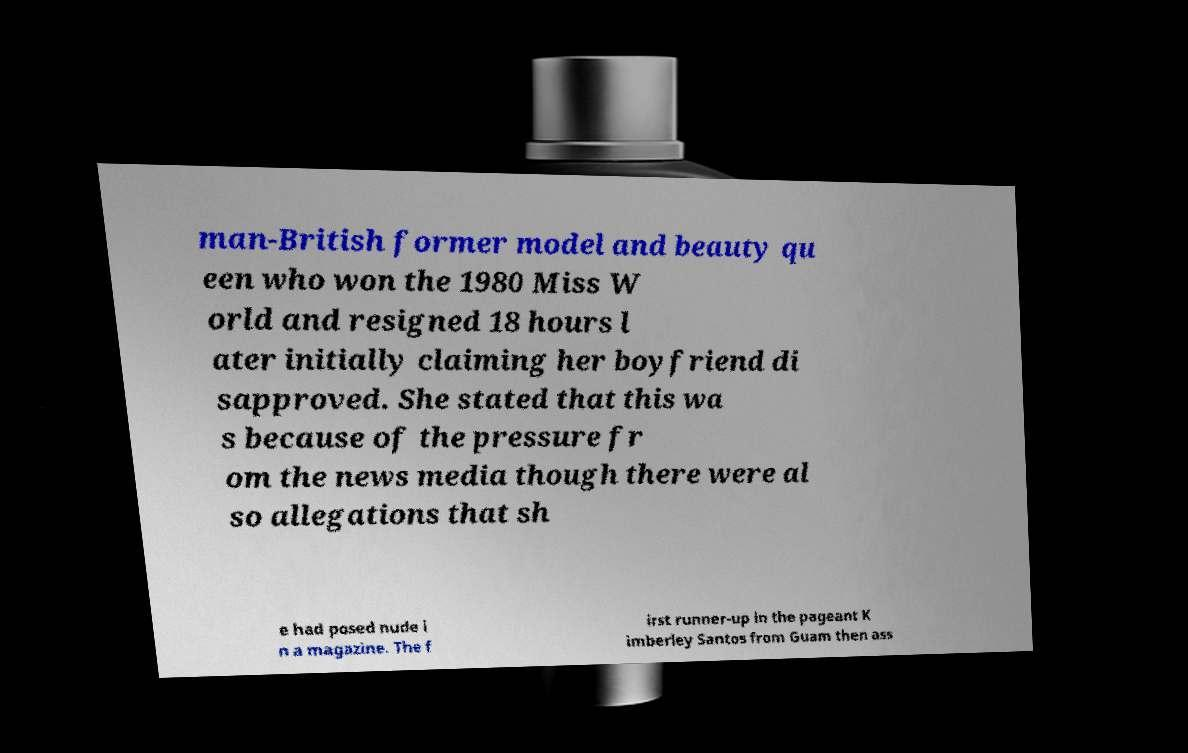I need the written content from this picture converted into text. Can you do that? man-British former model and beauty qu een who won the 1980 Miss W orld and resigned 18 hours l ater initially claiming her boyfriend di sapproved. She stated that this wa s because of the pressure fr om the news media though there were al so allegations that sh e had posed nude i n a magazine. The f irst runner-up in the pageant K imberley Santos from Guam then ass 